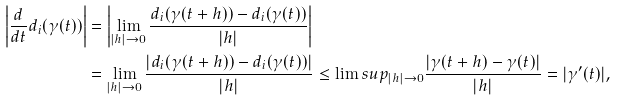<formula> <loc_0><loc_0><loc_500><loc_500>\left | \frac { d } { d t } d _ { i } ( \gamma ( t ) ) \right | & = \left | \lim _ { | h | \to 0 } \frac { d _ { i } ( \gamma ( t + h ) ) - d _ { i } ( \gamma ( t ) ) } { | h | } \right | \\ & = \lim _ { | h | \to 0 } \frac { | d _ { i } ( \gamma ( t + h ) ) - d _ { i } ( \gamma ( t ) ) | } { | h | } \leq \lim s u p _ { | h | \to 0 } \frac { | \gamma ( t + h ) - \gamma ( t ) | } { | h | } = | \gamma ^ { \prime } ( t ) | ,</formula> 